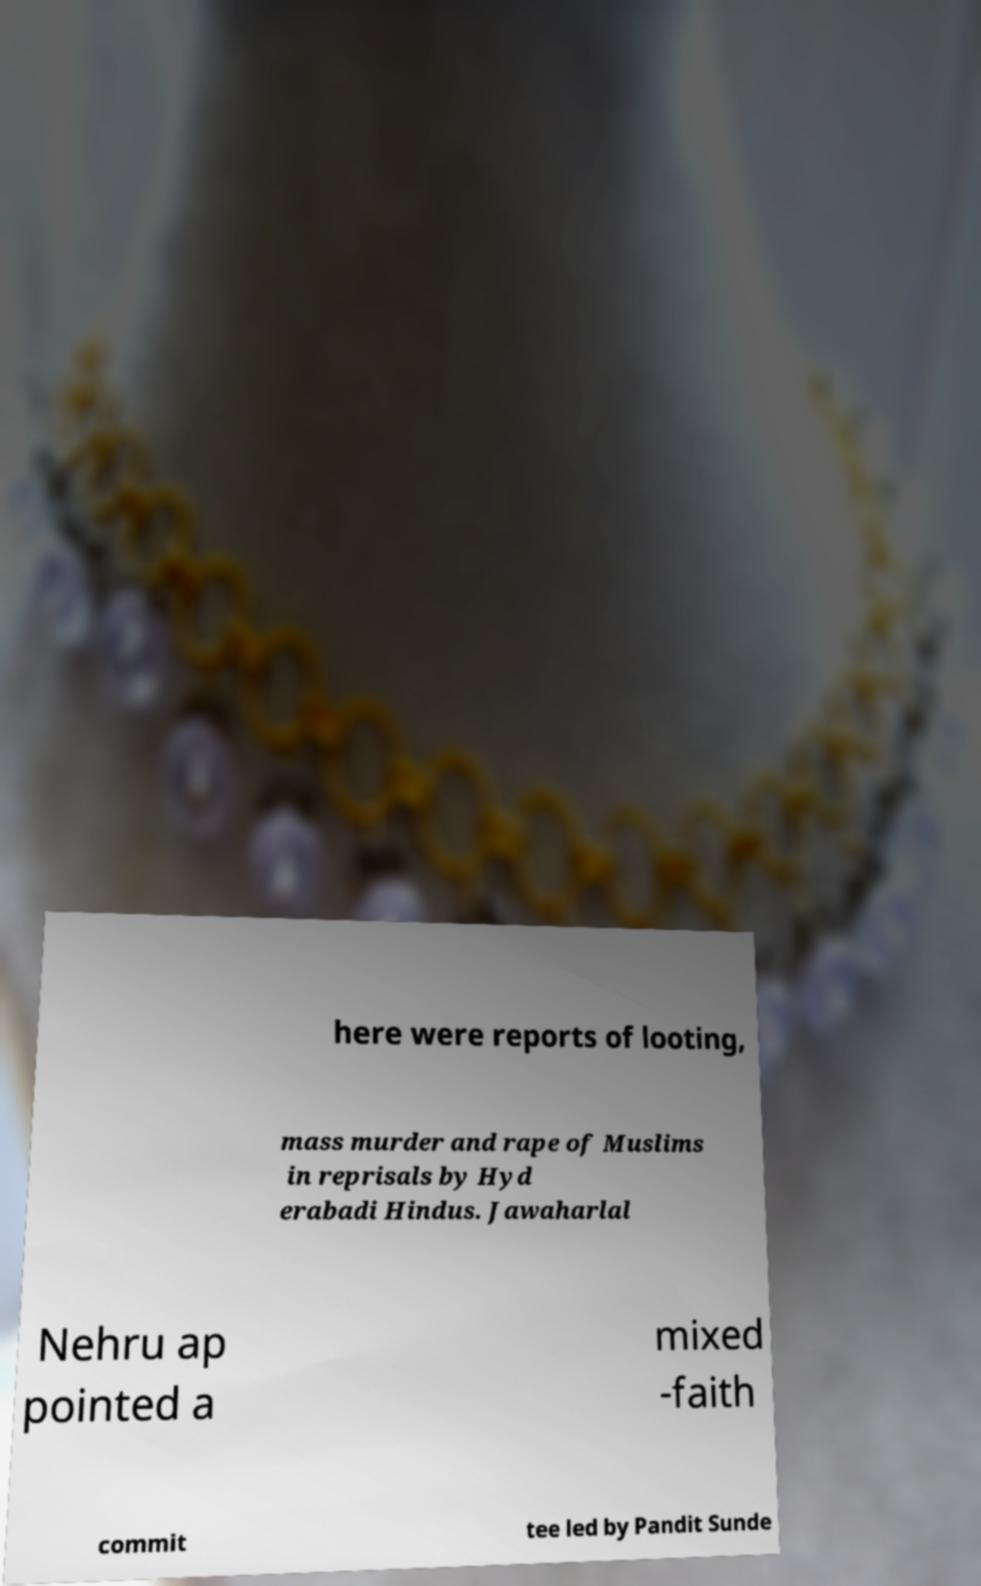Please identify and transcribe the text found in this image. here were reports of looting, mass murder and rape of Muslims in reprisals by Hyd erabadi Hindus. Jawaharlal Nehru ap pointed a mixed -faith commit tee led by Pandit Sunde 